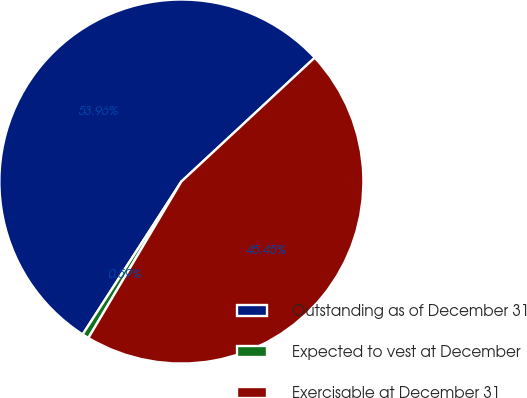Convert chart. <chart><loc_0><loc_0><loc_500><loc_500><pie_chart><fcel>Outstanding as of December 31<fcel>Expected to vest at December<fcel>Exercisable at December 31<nl><fcel>53.96%<fcel>0.59%<fcel>45.45%<nl></chart> 